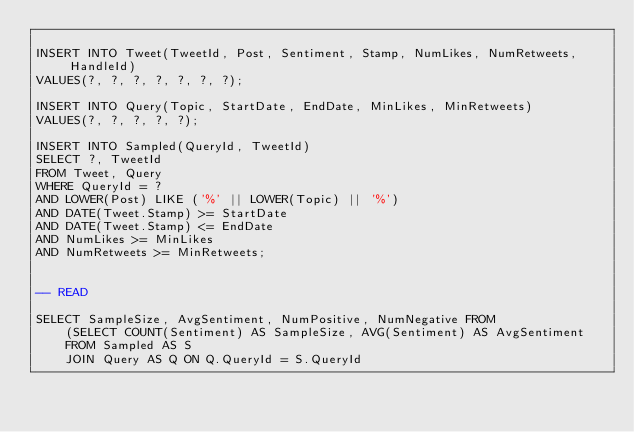<code> <loc_0><loc_0><loc_500><loc_500><_SQL_>
INSERT INTO Tweet(TweetId, Post, Sentiment, Stamp, NumLikes, NumRetweets, HandleId)
VALUES(?, ?, ?, ?, ?, ?, ?);

INSERT INTO Query(Topic, StartDate, EndDate, MinLikes, MinRetweets)
VALUES(?, ?, ?, ?, ?);

INSERT INTO Sampled(QueryId, TweetId)
SELECT ?, TweetId
FROM Tweet, Query
WHERE QueryId = ?
AND LOWER(Post) LIKE ('%' || LOWER(Topic) || '%')
AND DATE(Tweet.Stamp) >= StartDate
AND DATE(Tweet.Stamp) <= EndDate
AND NumLikes >= MinLikes
AND NumRetweets >= MinRetweets;


-- READ

SELECT SampleSize, AvgSentiment, NumPositive, NumNegative FROM
    (SELECT COUNT(Sentiment) AS SampleSize, AVG(Sentiment) AS AvgSentiment
    FROM Sampled AS S
    JOIN Query AS Q ON Q.QueryId = S.QueryId</code> 